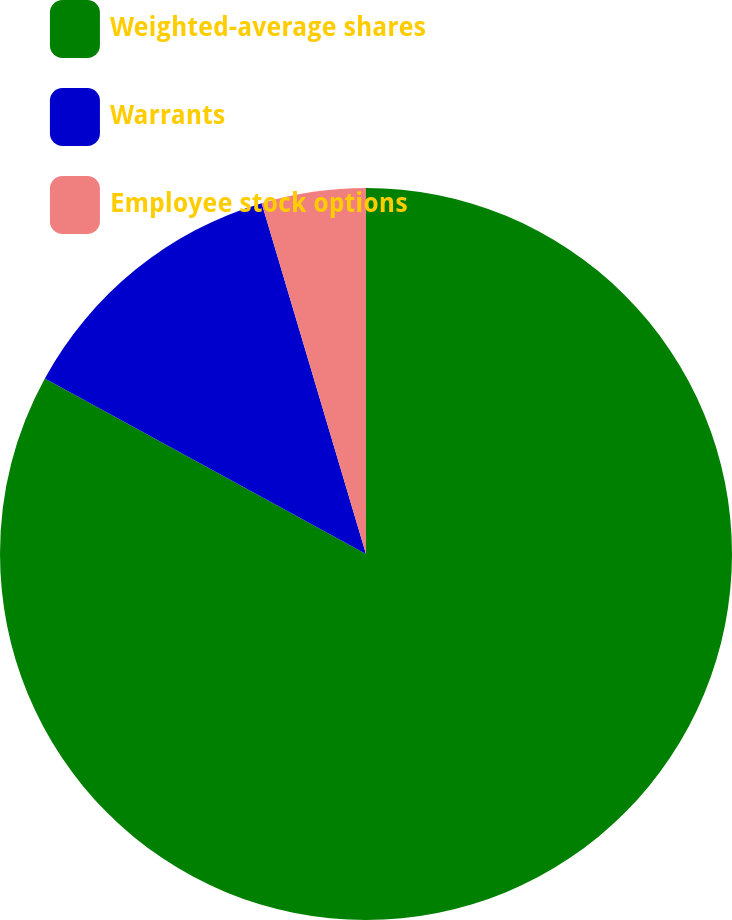Convert chart to OTSL. <chart><loc_0><loc_0><loc_500><loc_500><pie_chart><fcel>Weighted-average shares<fcel>Warrants<fcel>Employee stock options<nl><fcel>82.96%<fcel>12.44%<fcel>4.6%<nl></chart> 